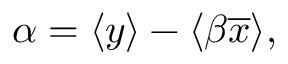<formula> <loc_0><loc_0><loc_500><loc_500>\alpha = \langle { y } \rangle - \langle \beta \overline { x } \rangle ,</formula> 